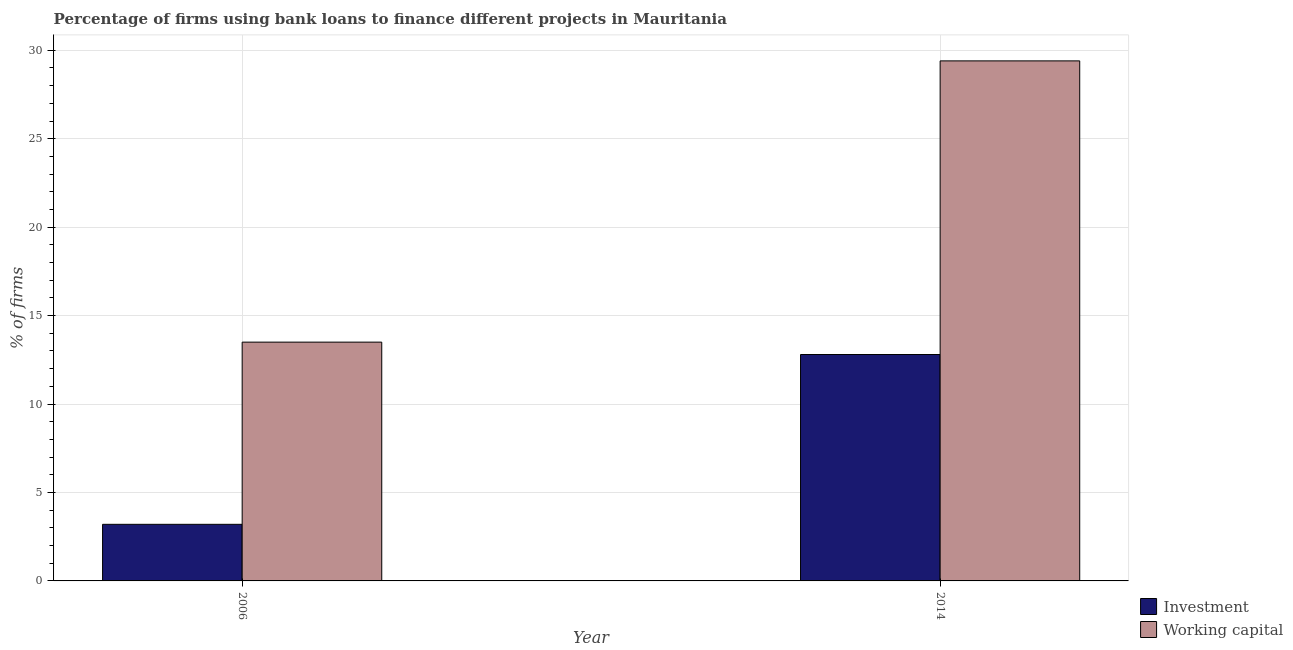Are the number of bars per tick equal to the number of legend labels?
Ensure brevity in your answer.  Yes. How many bars are there on the 1st tick from the left?
Offer a very short reply. 2. How many bars are there on the 1st tick from the right?
Provide a short and direct response. 2. In how many cases, is the number of bars for a given year not equal to the number of legend labels?
Your answer should be very brief. 0. What is the percentage of firms using banks to finance working capital in 2014?
Provide a succinct answer. 29.4. Across all years, what is the maximum percentage of firms using banks to finance working capital?
Your answer should be compact. 29.4. In which year was the percentage of firms using banks to finance working capital maximum?
Make the answer very short. 2014. What is the total percentage of firms using banks to finance investment in the graph?
Provide a short and direct response. 16. What is the difference between the percentage of firms using banks to finance investment in 2006 and that in 2014?
Offer a terse response. -9.6. What is the difference between the percentage of firms using banks to finance investment in 2014 and the percentage of firms using banks to finance working capital in 2006?
Your response must be concise. 9.6. What is the average percentage of firms using banks to finance working capital per year?
Keep it short and to the point. 21.45. What is the ratio of the percentage of firms using banks to finance working capital in 2006 to that in 2014?
Ensure brevity in your answer.  0.46. Is the percentage of firms using banks to finance working capital in 2006 less than that in 2014?
Your answer should be compact. Yes. What does the 2nd bar from the left in 2006 represents?
Your answer should be very brief. Working capital. What does the 1st bar from the right in 2014 represents?
Offer a very short reply. Working capital. How many bars are there?
Your answer should be compact. 4. How many years are there in the graph?
Ensure brevity in your answer.  2. What is the difference between two consecutive major ticks on the Y-axis?
Keep it short and to the point. 5. Are the values on the major ticks of Y-axis written in scientific E-notation?
Ensure brevity in your answer.  No. Does the graph contain any zero values?
Make the answer very short. No. Where does the legend appear in the graph?
Ensure brevity in your answer.  Bottom right. How are the legend labels stacked?
Keep it short and to the point. Vertical. What is the title of the graph?
Keep it short and to the point. Percentage of firms using bank loans to finance different projects in Mauritania. Does "Research and Development" appear as one of the legend labels in the graph?
Give a very brief answer. No. What is the label or title of the X-axis?
Provide a short and direct response. Year. What is the label or title of the Y-axis?
Your answer should be very brief. % of firms. What is the % of firms in Investment in 2014?
Provide a succinct answer. 12.8. What is the % of firms of Working capital in 2014?
Provide a short and direct response. 29.4. Across all years, what is the maximum % of firms of Working capital?
Keep it short and to the point. 29.4. What is the total % of firms in Working capital in the graph?
Give a very brief answer. 42.9. What is the difference between the % of firms in Investment in 2006 and that in 2014?
Your answer should be compact. -9.6. What is the difference between the % of firms of Working capital in 2006 and that in 2014?
Ensure brevity in your answer.  -15.9. What is the difference between the % of firms in Investment in 2006 and the % of firms in Working capital in 2014?
Offer a terse response. -26.2. What is the average % of firms in Working capital per year?
Your answer should be very brief. 21.45. In the year 2006, what is the difference between the % of firms in Investment and % of firms in Working capital?
Provide a succinct answer. -10.3. In the year 2014, what is the difference between the % of firms in Investment and % of firms in Working capital?
Give a very brief answer. -16.6. What is the ratio of the % of firms in Working capital in 2006 to that in 2014?
Ensure brevity in your answer.  0.46. What is the difference between the highest and the lowest % of firms of Investment?
Your response must be concise. 9.6. What is the difference between the highest and the lowest % of firms of Working capital?
Ensure brevity in your answer.  15.9. 